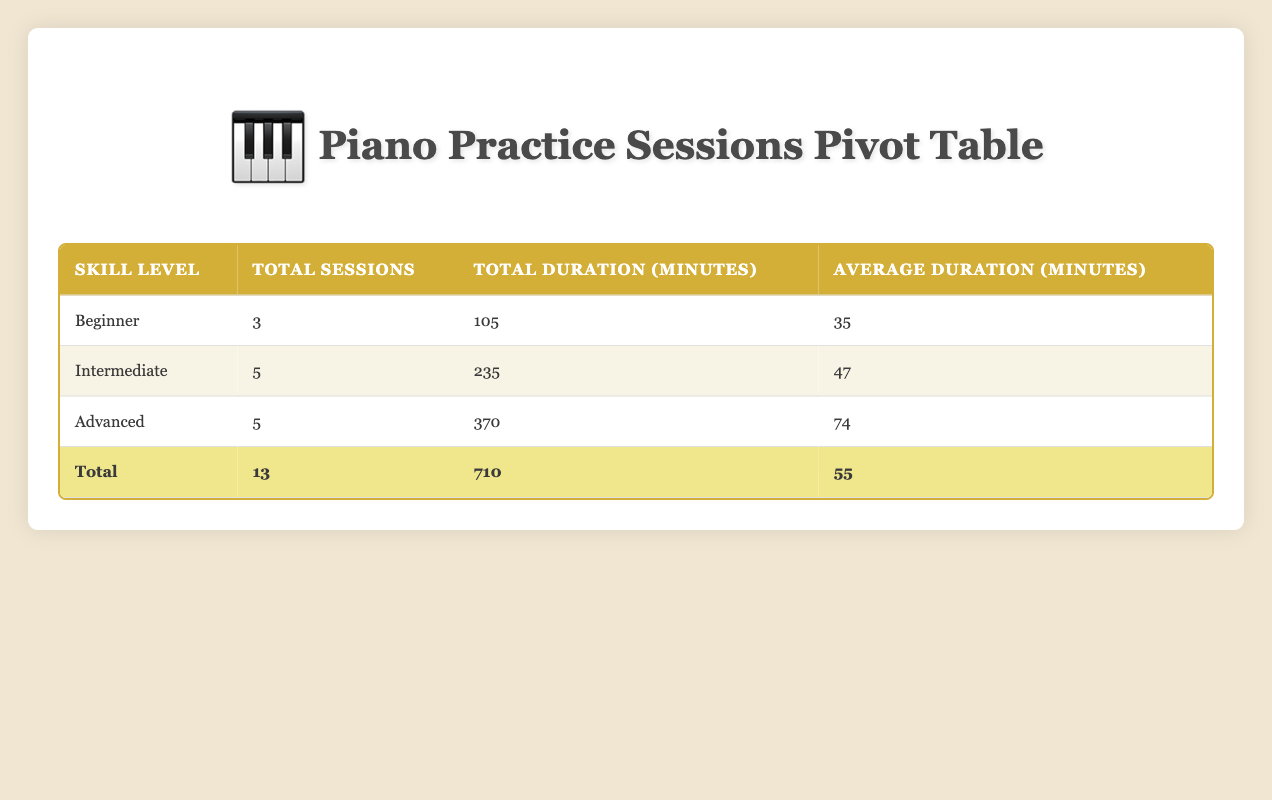What is the total number of practice sessions conducted for students at an advanced skill level? There are two rows in the table where the skill level is listed as Advanced: Ava Patel (two sessions) and Sophia Rodriguez (two sessions). Adding these gives us a total of 5 sessions for Advanced students.
Answer: 5 What is the average duration of practice sessions for Beginner students? There are 3 practice sessions for Beginner students. The durations are 30, 40, and 35 minutes. Summing these gives us 30 + 40 + 35 = 105 minutes. Dividing this total by the number of sessions (3) results in an average duration of 105/3 = 35 minutes.
Answer: 35 How many sessions had a duration longer than 60 minutes? Looking at the durations, there are two sessions with durations longer than 60 minutes: Ava Patel's session of 75 minutes and Sophia Rodriguez's session of 90 minutes. Thus, we find that there are 2 sessions longer than 60 minutes.
Answer: 2 Is the total duration of Intermediate sessions greater than that of Advanced sessions? The total duration of Intermediate sessions is calculated from the table: Emma Thompson (45 + 40 = 85), Oliver Harris (50 + 45 = 95), resulting in a total of 235 minutes. The Advanced sessions have 370 minutes. Comparing the two shows that 235 is not greater than 370.
Answer: No What is the total duration of all practice sessions in the table? To find the total duration, we add all the session durations: 45 + 30 + 60 + 50 + 75 + 40 + 35 + 90 + 55 + 65 + 40 + 80 + 45 = 710 minutes, confirming that the total duration is 710 minutes.
Answer: 710 How many students practiced using the Grand Piano? All entries in the table specify that the piano type used is "Grand Piano." Since there are 13 practice sessions recorded, it follows that 13 students practiced using the Grand Piano.
Answer: 13 What is the total number of sessions conducted for students aged 12 years? There are two students aged 12: Oliver Harris, who has two sessions (March and December) each of 50 and 45 minutes respectively. Therefore, the total sessions for students aged 12 is 2.
Answer: 2 Did any student practice for 90 minutes? Reviewing the durations, there is one session where a student practiced for 90 minutes: Sophia Rodriguez’s session. Thus, this statement is true.
Answer: Yes What is the average duration of all practice sessions? There are 13 sessions in total with a cumulative duration of 710 minutes. To find the average, we divide the total duration (710) by the number of sessions (13), resulting in an average duration of approximately 54.6 minutes, rounding gives us 55 minutes.
Answer: 55 